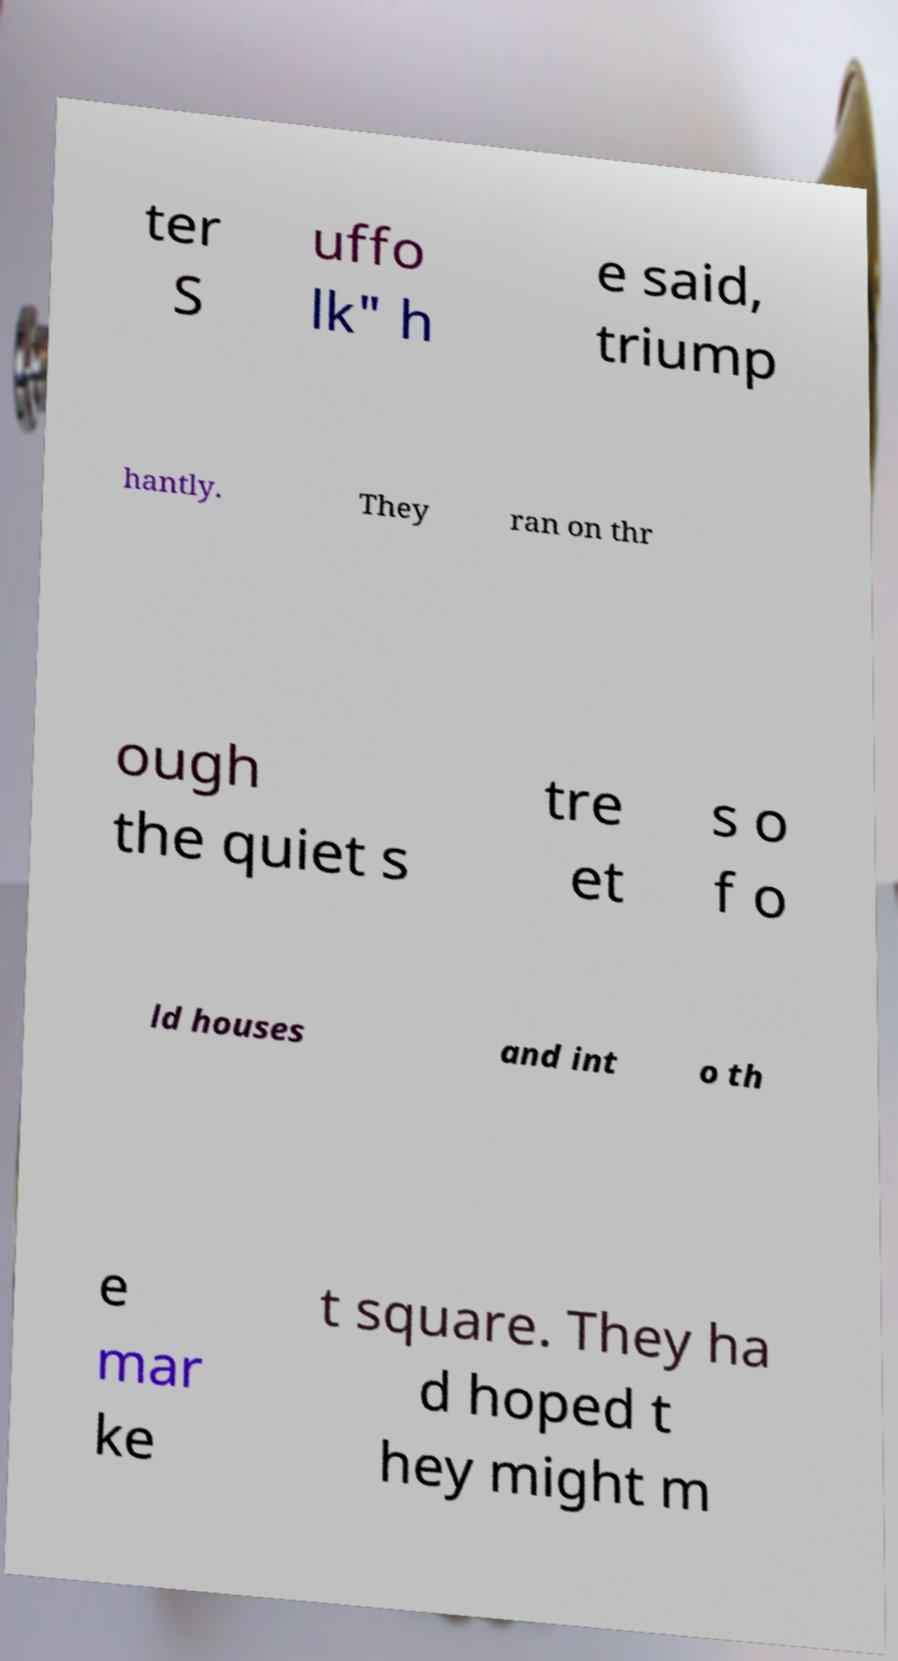Please read and relay the text visible in this image. What does it say? ter S uffo lk" h e said, triump hantly. They ran on thr ough the quiet s tre et s o f o ld houses and int o th e mar ke t square. They ha d hoped t hey might m 